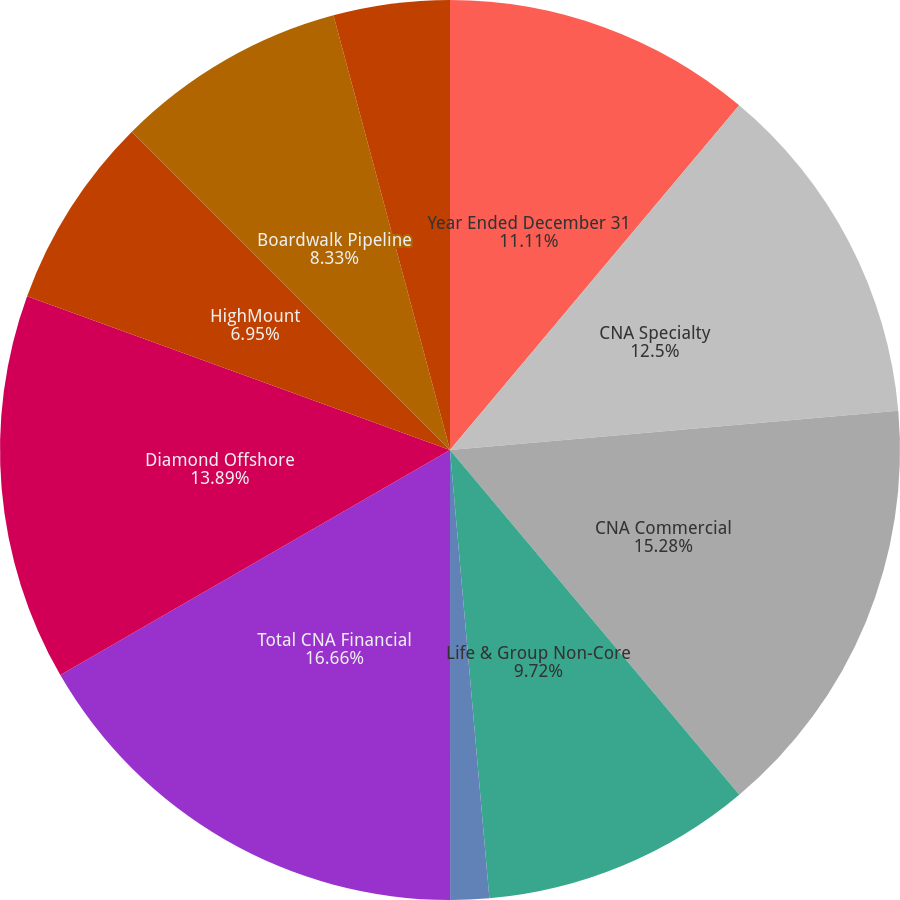Convert chart. <chart><loc_0><loc_0><loc_500><loc_500><pie_chart><fcel>Year Ended December 31<fcel>CNA Specialty<fcel>CNA Commercial<fcel>Life & Group Non-Core<fcel>Other Insurance<fcel>Total CNA Financial<fcel>Diamond Offshore<fcel>HighMount<fcel>Boardwalk Pipeline<fcel>Loews Hotels<nl><fcel>11.11%<fcel>12.5%<fcel>15.28%<fcel>9.72%<fcel>1.39%<fcel>16.67%<fcel>13.89%<fcel>6.95%<fcel>8.33%<fcel>4.17%<nl></chart> 